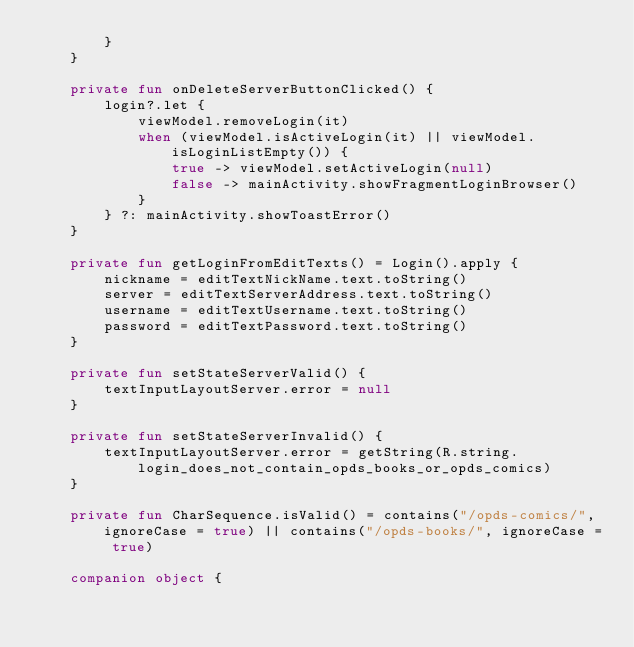Convert code to text. <code><loc_0><loc_0><loc_500><loc_500><_Kotlin_>        }
    }

    private fun onDeleteServerButtonClicked() {
        login?.let {
            viewModel.removeLogin(it)
            when (viewModel.isActiveLogin(it) || viewModel.isLoginListEmpty()) {
                true -> viewModel.setActiveLogin(null)
                false -> mainActivity.showFragmentLoginBrowser()
            }
        } ?: mainActivity.showToastError()
    }

    private fun getLoginFromEditTexts() = Login().apply {
        nickname = editTextNickName.text.toString()
        server = editTextServerAddress.text.toString()
        username = editTextUsername.text.toString()
        password = editTextPassword.text.toString()
    }

    private fun setStateServerValid() {
        textInputLayoutServer.error = null
    }

    private fun setStateServerInvalid() {
        textInputLayoutServer.error = getString(R.string.login_does_not_contain_opds_books_or_opds_comics)
    }

    private fun CharSequence.isValid() = contains("/opds-comics/", ignoreCase = true) || contains("/opds-books/", ignoreCase = true)

    companion object {</code> 